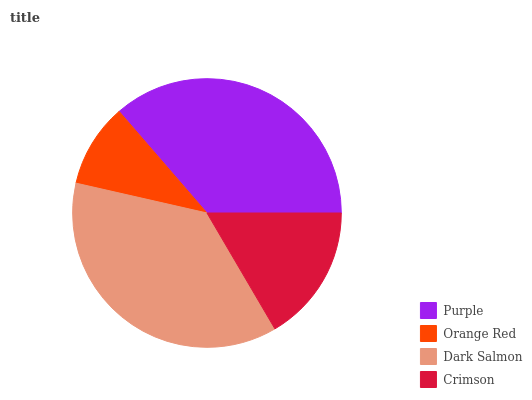Is Orange Red the minimum?
Answer yes or no. Yes. Is Dark Salmon the maximum?
Answer yes or no. Yes. Is Dark Salmon the minimum?
Answer yes or no. No. Is Orange Red the maximum?
Answer yes or no. No. Is Dark Salmon greater than Orange Red?
Answer yes or no. Yes. Is Orange Red less than Dark Salmon?
Answer yes or no. Yes. Is Orange Red greater than Dark Salmon?
Answer yes or no. No. Is Dark Salmon less than Orange Red?
Answer yes or no. No. Is Purple the high median?
Answer yes or no. Yes. Is Crimson the low median?
Answer yes or no. Yes. Is Crimson the high median?
Answer yes or no. No. Is Purple the low median?
Answer yes or no. No. 